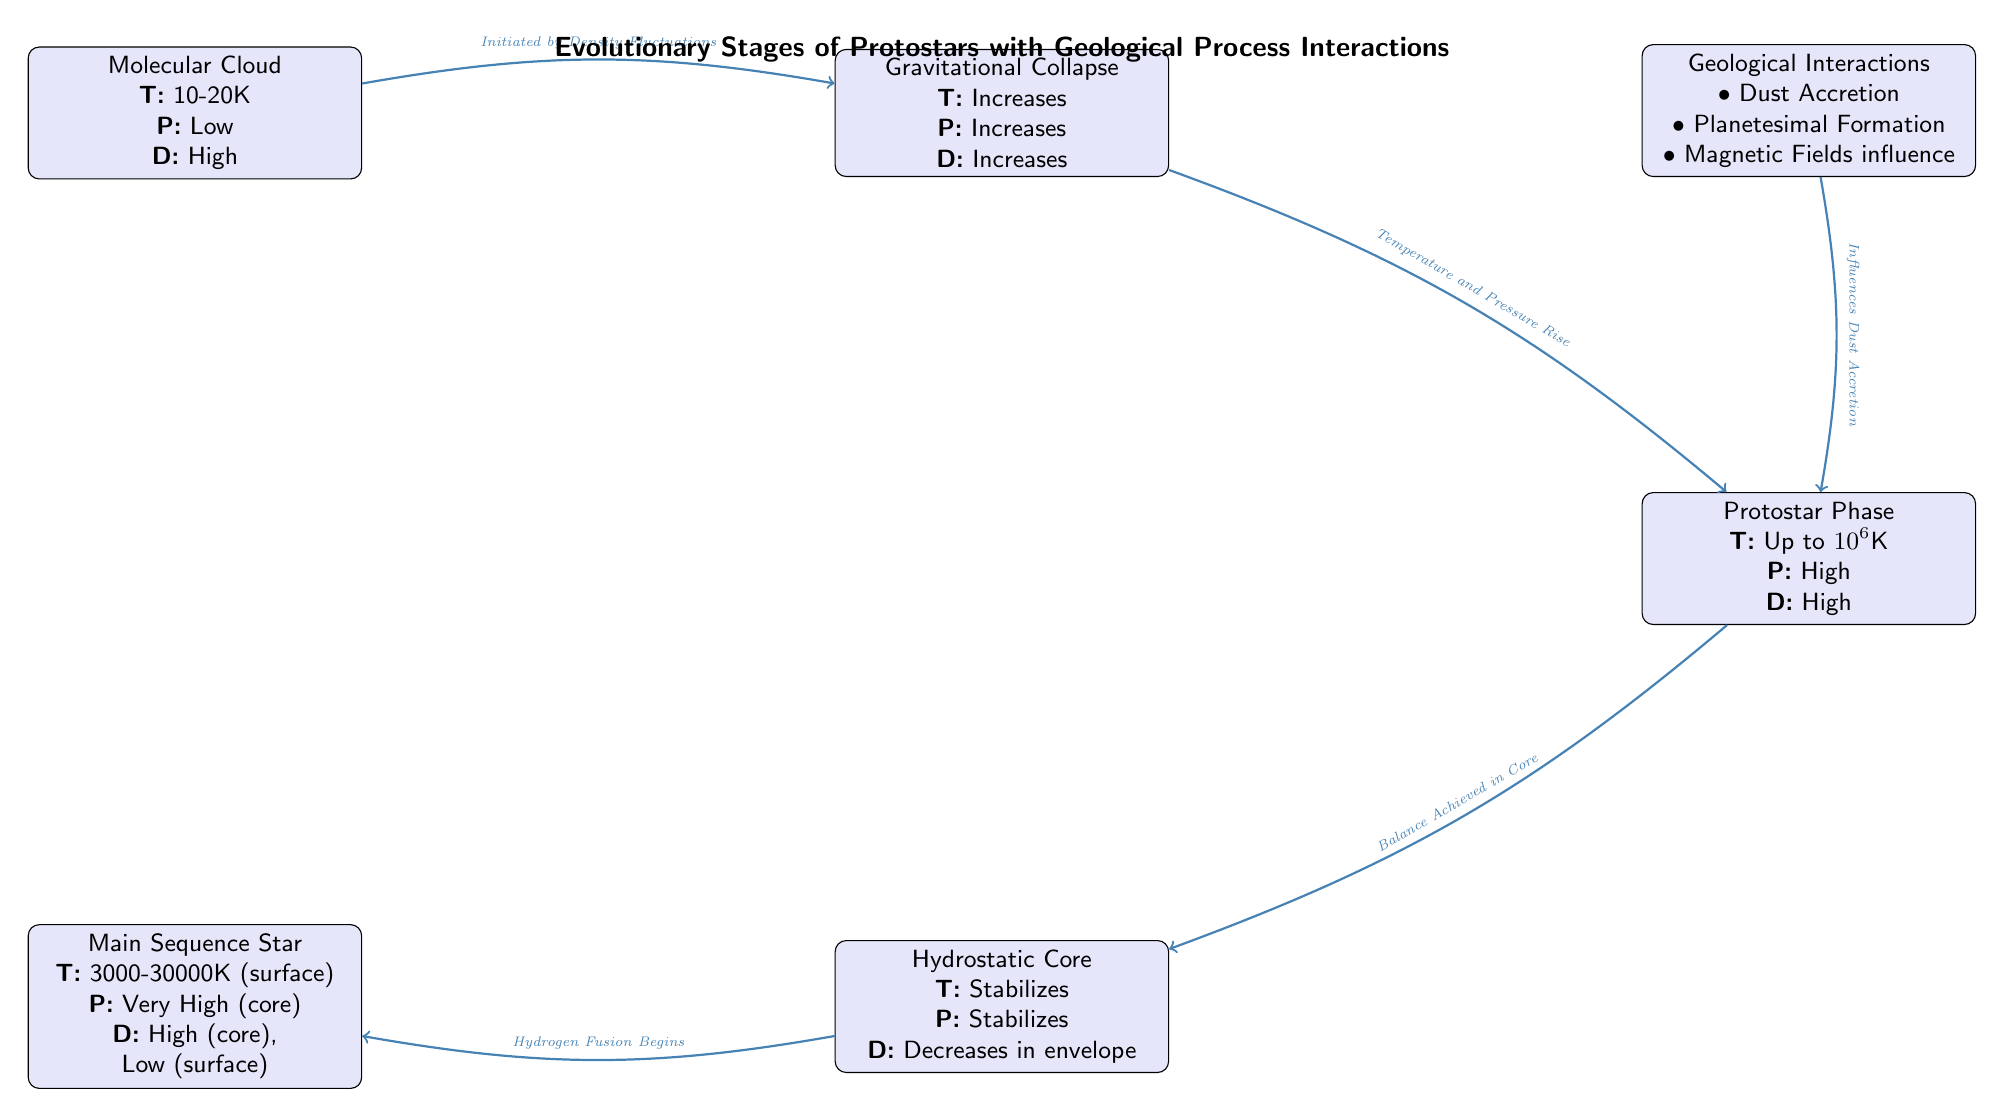What is the temperature range of the Molecular Cloud? The diagram states that the temperature of the Molecular Cloud is between 10-20K. This information can be directly found in the node labeled "Molecular Cloud."
Answer: 10-20K How many distinct evolutionary stages are shown in the diagram? By counting the labeled nodes, we identify five stages: Molecular Cloud, Gravitational Collapse, Protostar Phase, Hydrostatic Core, and Main Sequence Star.
Answer: 5 What process is initiated by Density Fluctuations? The diagram specifies that the Gravitational Collapse is initiated by Density Fluctuations, as indicated by the edge labeling connecting the Molecular Cloud to Gravitational Collapse.
Answer: Gravitational Collapse What happens to Temperature, Pressure, and Density during the transition from Gravitational Collapse to Protostar Phase? In the transition from Gravitational Collapse to Protostar Phase, Temperature, Pressure, and Density all increase, as indicated in the respective nodes.
Answer: Increases Which geological interactions influence Dust Accretion? The diagram indicates that Geological Interactions influence Dust Accretion; however, the important note is that certain processes like Planetesimal Formation and Magnetic Fields are also mentioned in the same node for context.
Answer: Geological Interactions What happens to Density in the Hydrostatic Core compared to the Protostar Phase? According to the Hydrostatic Core node, Density stabilizes and decreases in the envelope, contrasting with the high Density indicated in the Protostar Phase. This shows a change in Density from high to decreased in the specific context of the core.
Answer: Decreases in envelope What is the relationship between the Protostar Phase and Geological Interactions? The diagram illustrates that Geological Interactions influence Dust Accretion, which feeds into the Protostar Phase. This indicates a direct impact from geological processes on the formation characteristics of the Protostar.
Answer: Influences Dust Accretion What is the temperature in the Main Sequence Star? The diagram provides a temperature range for the Main Sequence Star, stating that it is between 3000-30000K for the surface. This specific range is outlined within the node dedicated to the Main Sequence Star.
Answer: 3000-30000K (surface) 